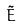Convert formula to latex. <formula><loc_0><loc_0><loc_500><loc_500>\tilde { E }</formula> 